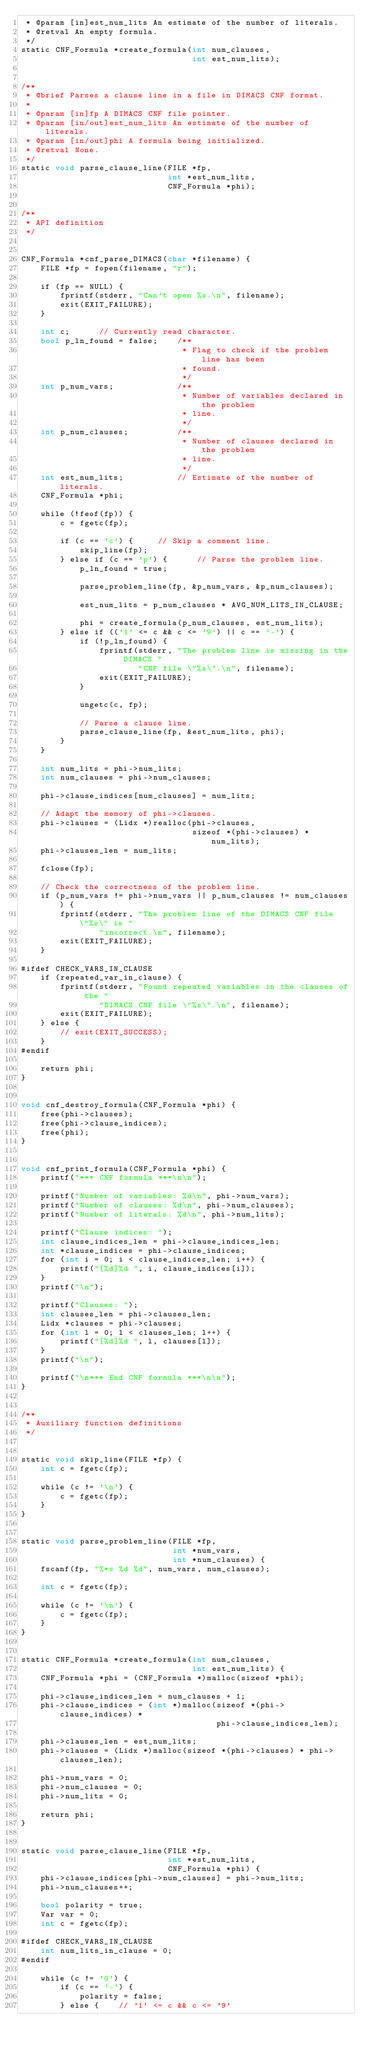<code> <loc_0><loc_0><loc_500><loc_500><_Cuda_> * @param [in]est_num_lits An estimate of the number of literals.
 * @retval An empty formula.
 */
static CNF_Formula *create_formula(int num_clauses,
                                   int est_num_lits);


/**
 * @brief Parses a clause line in a file in DIMACS CNF format.
 * 
 * @param [in]fp A DIMACS CNF file pointer.
 * @param [in/out]est_num_lits An estimate of the number of literals.
 * @param [in/out]phi A formula being initialized.
 * @retval None.
 */
static void parse_clause_line(FILE *fp,
                              int *est_num_lits,
                              CNF_Formula *phi);


/**
 * API definition
 */


CNF_Formula *cnf_parse_DIMACS(char *filename) {
    FILE *fp = fopen(filename, "r");

    if (fp == NULL) {
        fprintf(stderr, "Can't open %s.\n", filename);
        exit(EXIT_FAILURE);
    }

    int c;      // Currently read character.
    bool p_ln_found = false;    /**
                                 * Flag to check if the problem line has been
                                 * found.
                                 */
    int p_num_vars;             /**
                                 * Number of variables declared in the problem
                                 * line.
                                 */
    int p_num_clauses;          /**
                                 * Number of clauses declared in the problem
                                 * line.
                                 */
    int est_num_lits;           // Estimate of the number of literals.
    CNF_Formula *phi;

    while (!feof(fp)) {
        c = fgetc(fp);

        if (c == 'c') {     // Skip a comment line.
            skip_line(fp);
        } else if (c == 'p') {      // Parse the problem line.
            p_ln_found = true;

            parse_problem_line(fp, &p_num_vars, &p_num_clauses);

            est_num_lits = p_num_clauses * AVG_NUM_LITS_IN_CLAUSE;

            phi = create_formula(p_num_clauses, est_num_lits);
        } else if (('1' <= c && c <= '9') || c == '-') {
            if (!p_ln_found) {
                fprintf(stderr, "The problem line is missing in the DIMACS "
                        "CNF file \"%s\".\n", filename);
                exit(EXIT_FAILURE);
            }

            ungetc(c, fp);

            // Parse a clause line.
            parse_clause_line(fp, &est_num_lits, phi);
        }
    }

    int num_lits = phi->num_lits;
    int num_clauses = phi->num_clauses;

    phi->clause_indices[num_clauses] = num_lits;

    // Adapt the memory of phi->clauses.
    phi->clauses = (Lidx *)realloc(phi->clauses,
                                   sizeof *(phi->clauses) * num_lits);
    phi->clauses_len = num_lits;

    fclose(fp);

    // Check the correctness of the problem line.
    if (p_num_vars != phi->num_vars || p_num_clauses != num_clauses) {
        fprintf(stderr, "The problem line of the DIMACS CNF file \"%s\" is "
                "incorrect.\n", filename);
        exit(EXIT_FAILURE);
    }

#ifdef CHECK_VARS_IN_CLAUSE
    if (repeated_var_in_clause) {
        fprintf(stderr, "Found repeated variables in the clauses of the "
                "DIMACS CNF file \"%s\".\n", filename);
        exit(EXIT_FAILURE);
    } else {
        // exit(EXIT_SUCCESS);
    }
#endif

    return phi;
}


void cnf_destroy_formula(CNF_Formula *phi) {
    free(phi->clauses);
    free(phi->clause_indices);
    free(phi);
}


void cnf_print_formula(CNF_Formula *phi) {
    printf("*** CNF formula ***\n\n");

    printf("Number of variables: %d\n", phi->num_vars);
    printf("Number of clauses: %d\n", phi->num_clauses);
    printf("Number of literals: %d\n", phi->num_lits);

    printf("Clause indices: ");
    int clause_indices_len = phi->clause_indices_len;
    int *clause_indices = phi->clause_indices;
    for (int i = 0; i < clause_indices_len; i++) {
        printf("[%d]%d ", i, clause_indices[i]);
    }
    printf("\n");

    printf("Clauses: ");
    int clauses_len = phi->clauses_len;
    Lidx *clauses = phi->clauses;
    for (int l = 0; l < clauses_len; l++) {
        printf("[%d]%d ", l, clauses[l]);
    }
    printf("\n");

    printf("\n*** End CNF formula ***\n\n");
}


/**
 * Auxiliary function definitions
 */


static void skip_line(FILE *fp) {
    int c = fgetc(fp);

    while (c != '\n') {
        c = fgetc(fp);
    }
}


static void parse_problem_line(FILE *fp,
                               int *num_vars,
                               int *num_clauses) {
    fscanf(fp, "%*s %d %d", num_vars, num_clauses);

    int c = fgetc(fp);

    while (c != '\n') {
        c = fgetc(fp);
    }
}


static CNF_Formula *create_formula(int num_clauses,
                                   int est_num_lits) {
    CNF_Formula *phi = (CNF_Formula *)malloc(sizeof *phi);

    phi->clause_indices_len = num_clauses + 1;
    phi->clause_indices = (int *)malloc(sizeof *(phi->clause_indices) *
                                        phi->clause_indices_len);

    phi->clauses_len = est_num_lits;
    phi->clauses = (Lidx *)malloc(sizeof *(phi->clauses) * phi->clauses_len);

    phi->num_vars = 0;
    phi->num_clauses = 0;
    phi->num_lits = 0;

    return phi;
}


static void parse_clause_line(FILE *fp,
                              int *est_num_lits,
                              CNF_Formula *phi) {
    phi->clause_indices[phi->num_clauses] = phi->num_lits;
    phi->num_clauses++;

    bool polarity = true;
    Var var = 0;
    int c = fgetc(fp);

#ifdef CHECK_VARS_IN_CLAUSE
    int num_lits_in_clause = 0;
#endif

    while (c != '0') {
        if (c == '-') {
            polarity = false;
        } else {    // '1' <= c && c <= '9'</code> 